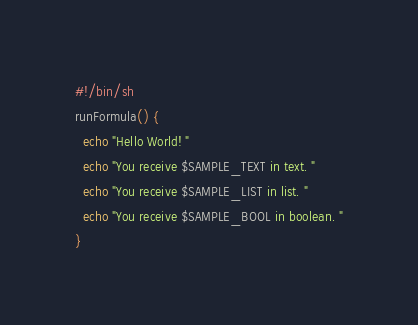<code> <loc_0><loc_0><loc_500><loc_500><_Bash_>#!/bin/sh
runFormula() {
  echo "Hello World! "
  echo "You receive $SAMPLE_TEXT in text. "
  echo "You receive $SAMPLE_LIST in list. "
  echo "You receive $SAMPLE_BOOL in boolean. "
}
</code> 